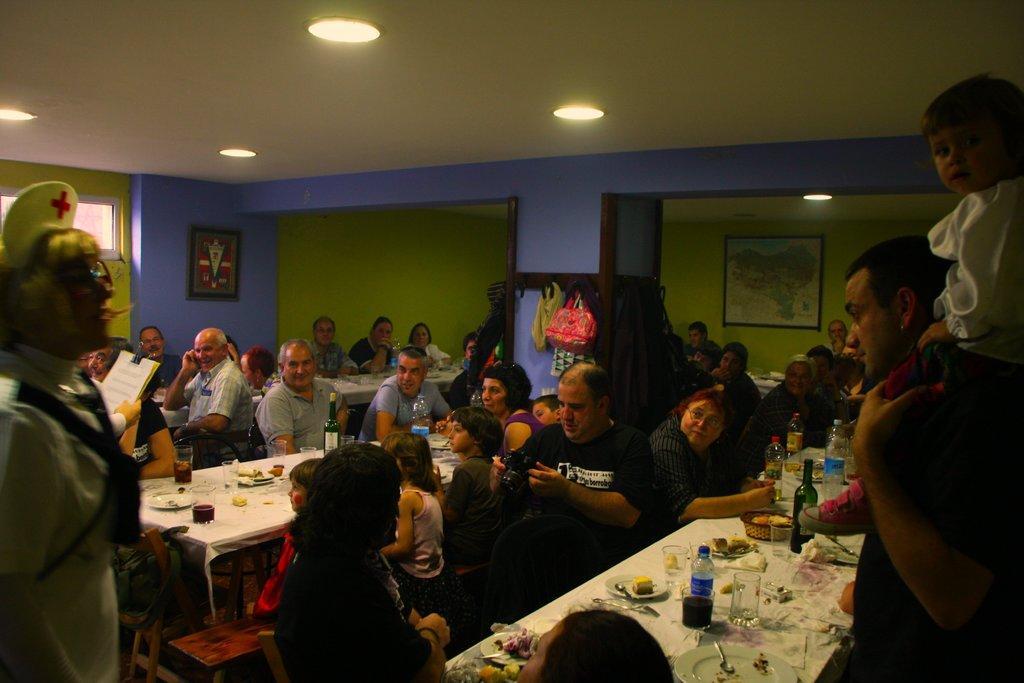How would you summarize this image in a sentence or two? In this picture there are few people standing over here and some of them are sitting, they have a table in front of them, they have water bottle and food stuff. 